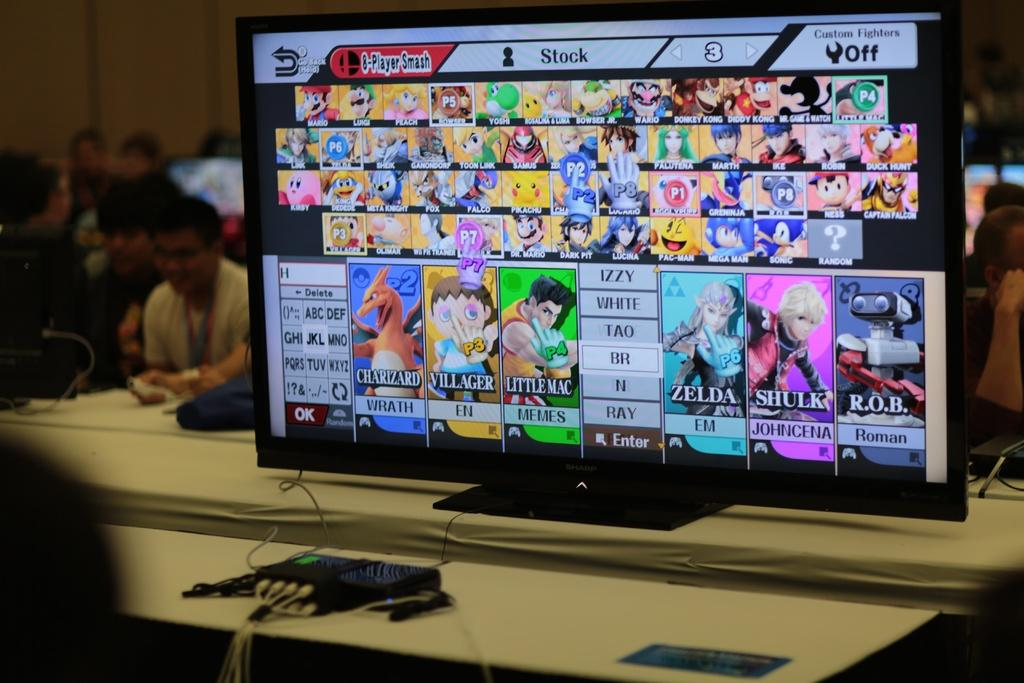<image>
Create a compact narrative representing the image presented. A television screen displaying the character select screen for super smash bros. 